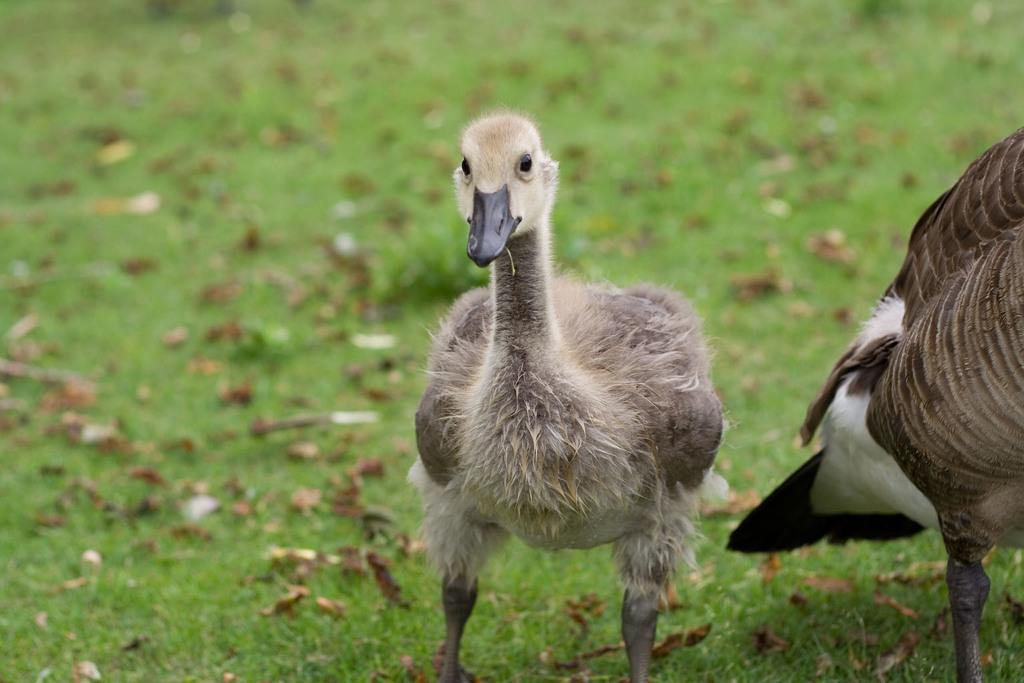In one or two sentences, can you explain what this image depicts? In the middle of the picture, we see a duck. It has a black beak and it is looking at the camera. At the bottom of the picture, we see the grass and dried leaves. In the background, it is blurred. 